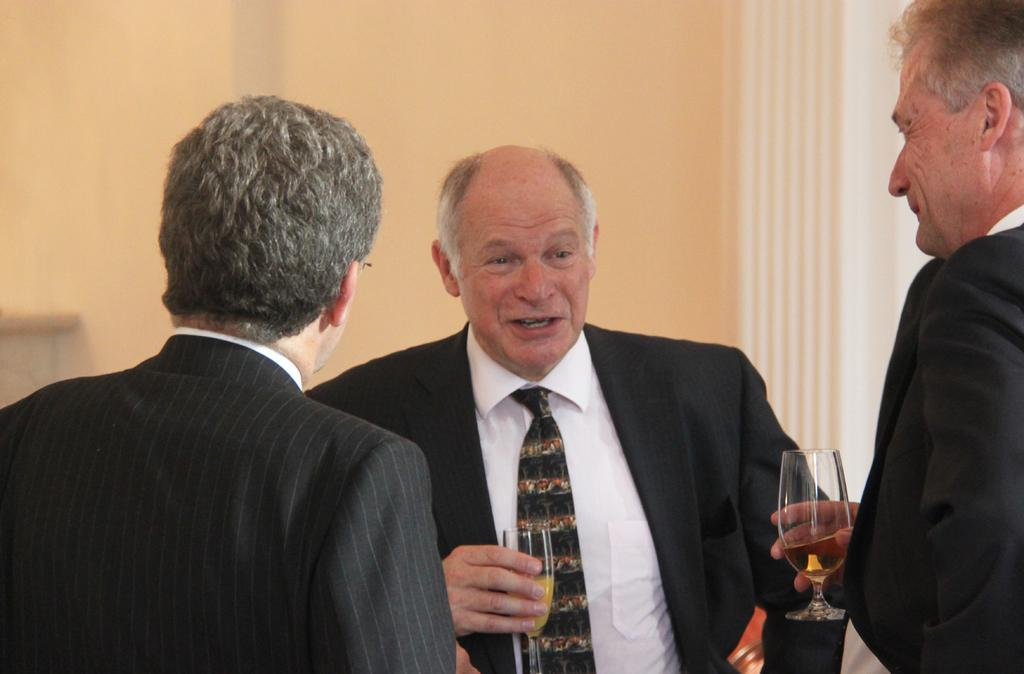What are the persons in the image wearing? The persons in the image are wearing coats. What are some of the persons holding in their hands? Some persons are holding glasses in their hands. What can be seen in the background of the image? There is a wall visible in the background of the image. What type of hospital can be seen in the image? There is no hospital present in the image. How does the servant look in the image? There is no servant present in the image. 